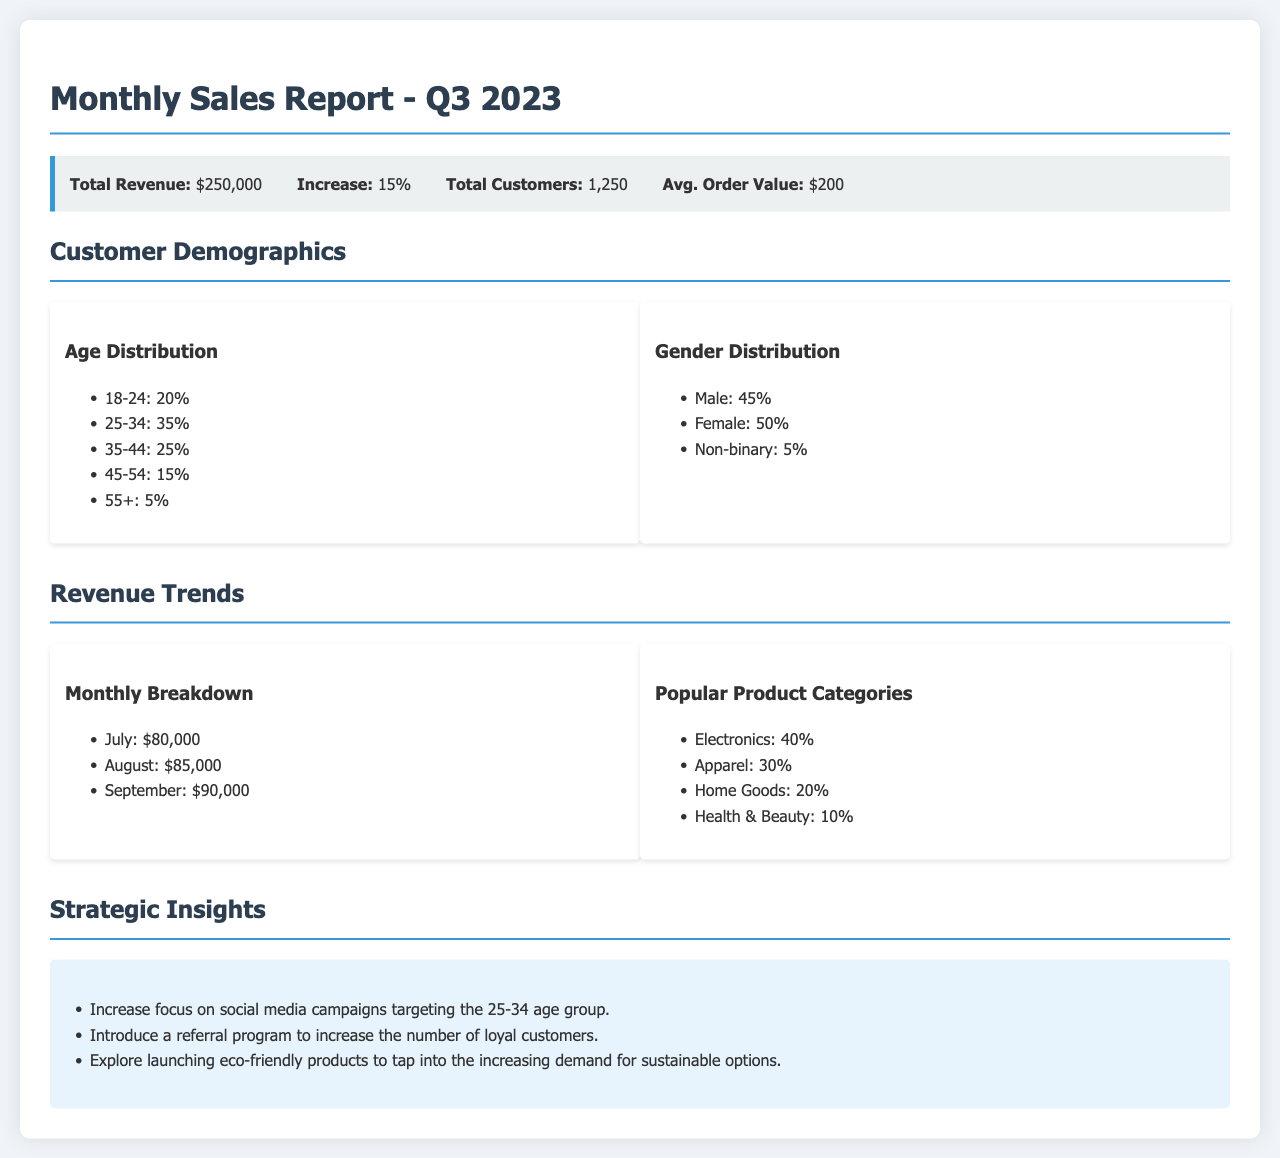what was the total revenue for Q3 2023? The total revenue is stated in the summary box as $250,000.
Answer: $250,000 what was the percentage increase in revenue? The document indicates an increase of 15% in revenue.
Answer: 15% how many total customers were there? The total number of customers is listed as 1,250 in the summary box.
Answer: 1,250 which age group has the highest customer percentage? The age group 25-34 accounts for the highest percentage of customers at 35%.
Answer: 25-34 what month had the highest revenue in Q3? According to the monthly breakdown, September had the highest revenue at $90,000.
Answer: September which product category generated the most revenue percentage? The product category Electronics generated the highest revenue percentage, at 40%.
Answer: Electronics what gender group constituted the largest share of customers? The document shows that Female customers constituted the largest share, at 50%.
Answer: Female what strategic insight suggests a new initiative? The introduction of a referral program is suggested as a new initiative in the strategic insights.
Answer: Referral program how much revenue was generated in July? The document states that revenue for July was $80,000.
Answer: $80,000 